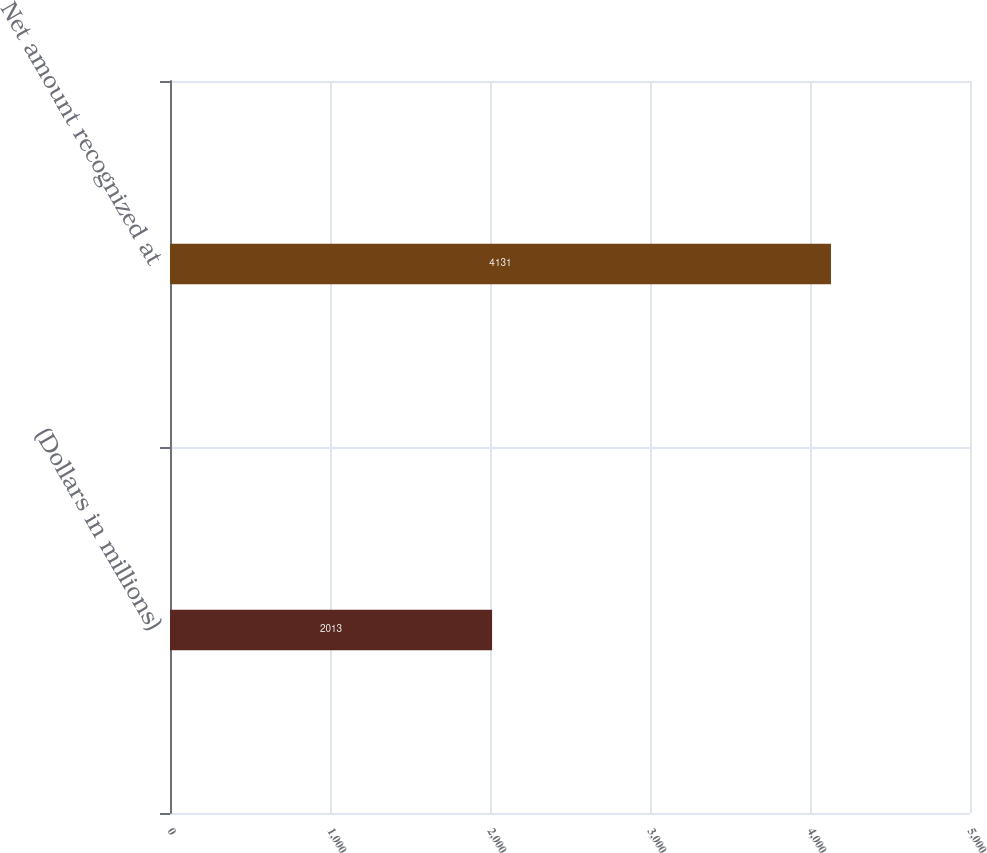Convert chart to OTSL. <chart><loc_0><loc_0><loc_500><loc_500><bar_chart><fcel>(Dollars in millions)<fcel>Net amount recognized at<nl><fcel>2013<fcel>4131<nl></chart> 